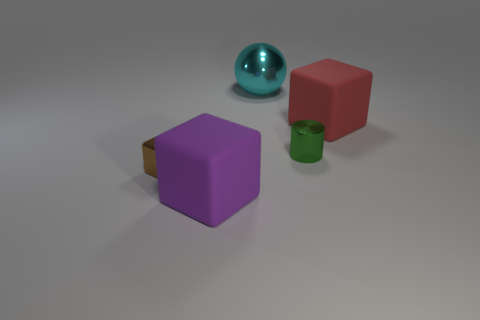Does the matte block that is to the left of the green object have the same size as the brown metallic object behind the big purple matte thing?
Provide a short and direct response. No. There is a green metallic object; are there any tiny things behind it?
Your response must be concise. No. What color is the rubber block to the left of the tiny shiny thing right of the purple block?
Keep it short and to the point. Purple. Are there fewer big red rubber objects than cyan rubber balls?
Ensure brevity in your answer.  No. What number of purple matte objects have the same shape as the big red object?
Your answer should be very brief. 1. There is another object that is the same size as the brown object; what color is it?
Your answer should be very brief. Green. Are there the same number of objects left of the purple matte cube and small green cylinders that are left of the red rubber thing?
Give a very brief answer. Yes. Is there a red rubber cube of the same size as the cyan metallic ball?
Give a very brief answer. Yes. The brown metal thing has what size?
Provide a short and direct response. Small. Are there the same number of large purple rubber blocks behind the large metallic sphere and shiny spheres?
Provide a succinct answer. No. 